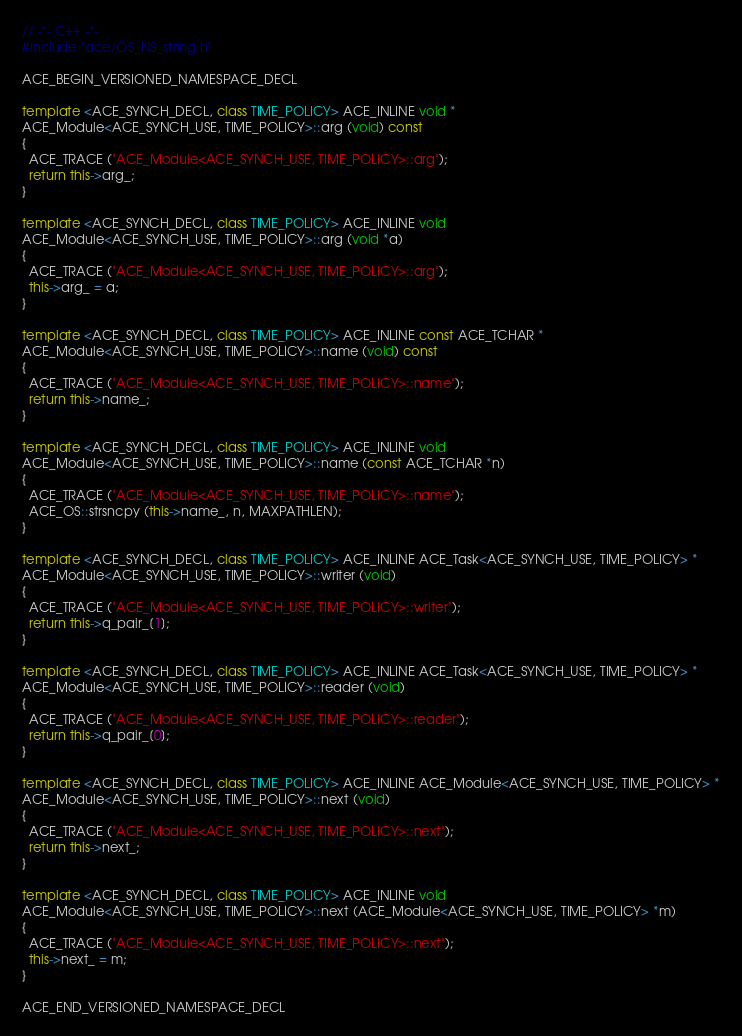<code> <loc_0><loc_0><loc_500><loc_500><_C++_>// -*- C++ -*-
#include "ace/OS_NS_string.h"

ACE_BEGIN_VERSIONED_NAMESPACE_DECL

template <ACE_SYNCH_DECL, class TIME_POLICY> ACE_INLINE void *
ACE_Module<ACE_SYNCH_USE, TIME_POLICY>::arg (void) const
{
  ACE_TRACE ("ACE_Module<ACE_SYNCH_USE, TIME_POLICY>::arg");
  return this->arg_;
}

template <ACE_SYNCH_DECL, class TIME_POLICY> ACE_INLINE void
ACE_Module<ACE_SYNCH_USE, TIME_POLICY>::arg (void *a)
{
  ACE_TRACE ("ACE_Module<ACE_SYNCH_USE, TIME_POLICY>::arg");
  this->arg_ = a;
}

template <ACE_SYNCH_DECL, class TIME_POLICY> ACE_INLINE const ACE_TCHAR *
ACE_Module<ACE_SYNCH_USE, TIME_POLICY>::name (void) const
{
  ACE_TRACE ("ACE_Module<ACE_SYNCH_USE, TIME_POLICY>::name");
  return this->name_;
}

template <ACE_SYNCH_DECL, class TIME_POLICY> ACE_INLINE void
ACE_Module<ACE_SYNCH_USE, TIME_POLICY>::name (const ACE_TCHAR *n)
{
  ACE_TRACE ("ACE_Module<ACE_SYNCH_USE, TIME_POLICY>::name");
  ACE_OS::strsncpy (this->name_, n, MAXPATHLEN);
}

template <ACE_SYNCH_DECL, class TIME_POLICY> ACE_INLINE ACE_Task<ACE_SYNCH_USE, TIME_POLICY> *
ACE_Module<ACE_SYNCH_USE, TIME_POLICY>::writer (void)
{
  ACE_TRACE ("ACE_Module<ACE_SYNCH_USE, TIME_POLICY>::writer");
  return this->q_pair_[1];
}

template <ACE_SYNCH_DECL, class TIME_POLICY> ACE_INLINE ACE_Task<ACE_SYNCH_USE, TIME_POLICY> *
ACE_Module<ACE_SYNCH_USE, TIME_POLICY>::reader (void)
{
  ACE_TRACE ("ACE_Module<ACE_SYNCH_USE, TIME_POLICY>::reader");
  return this->q_pair_[0];
}

template <ACE_SYNCH_DECL, class TIME_POLICY> ACE_INLINE ACE_Module<ACE_SYNCH_USE, TIME_POLICY> *
ACE_Module<ACE_SYNCH_USE, TIME_POLICY>::next (void)
{
  ACE_TRACE ("ACE_Module<ACE_SYNCH_USE, TIME_POLICY>::next");
  return this->next_;
}

template <ACE_SYNCH_DECL, class TIME_POLICY> ACE_INLINE void
ACE_Module<ACE_SYNCH_USE, TIME_POLICY>::next (ACE_Module<ACE_SYNCH_USE, TIME_POLICY> *m)
{
  ACE_TRACE ("ACE_Module<ACE_SYNCH_USE, TIME_POLICY>::next");
  this->next_ = m;
}

ACE_END_VERSIONED_NAMESPACE_DECL
</code> 